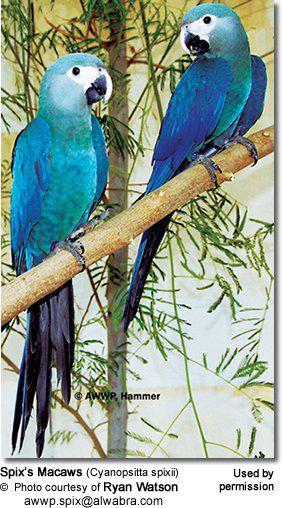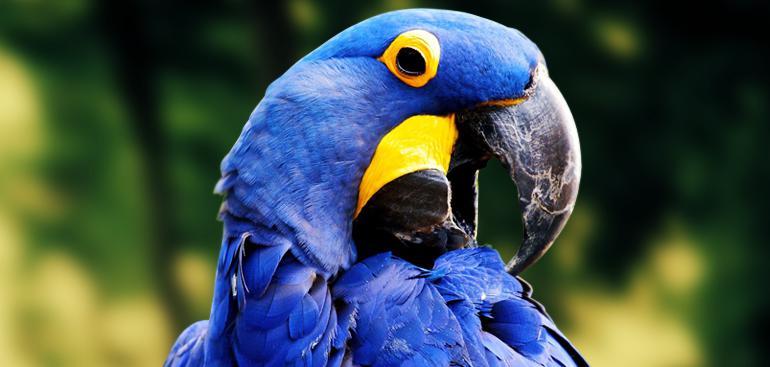The first image is the image on the left, the second image is the image on the right. Assess this claim about the two images: "There are at most 3 parrots.". Correct or not? Answer yes or no. Yes. The first image is the image on the left, the second image is the image on the right. Examine the images to the left and right. Is the description "In one image two parrots are standing on a branch and in the other there's only one parrot" accurate? Answer yes or no. Yes. 